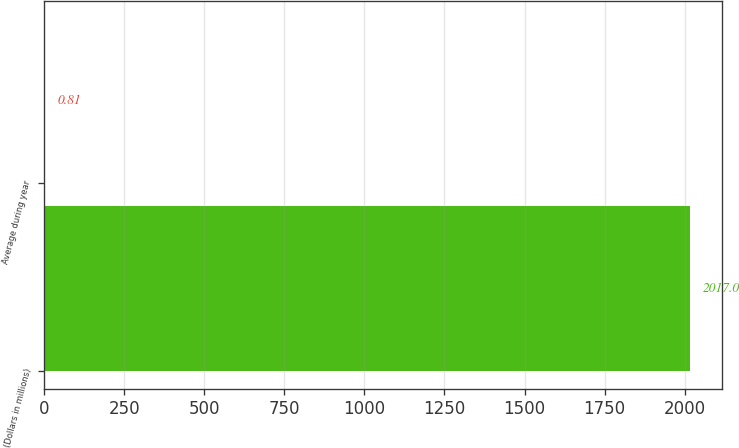<chart> <loc_0><loc_0><loc_500><loc_500><bar_chart><fcel>(Dollars in millions)<fcel>Average during year<nl><fcel>2017<fcel>0.81<nl></chart> 